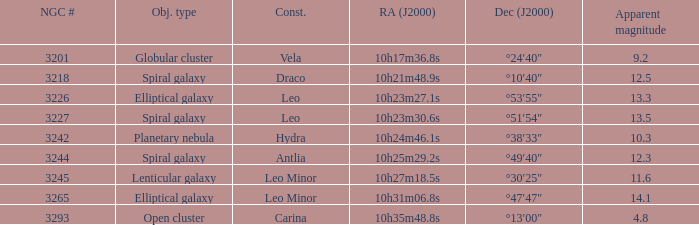What is the sum of NGC numbers for Constellation vela? 3201.0. 